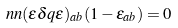<formula> <loc_0><loc_0><loc_500><loc_500>\ n n ( \epsilon \delta q \epsilon ) _ { a b } ( 1 - \epsilon _ { a b } ) = 0</formula> 